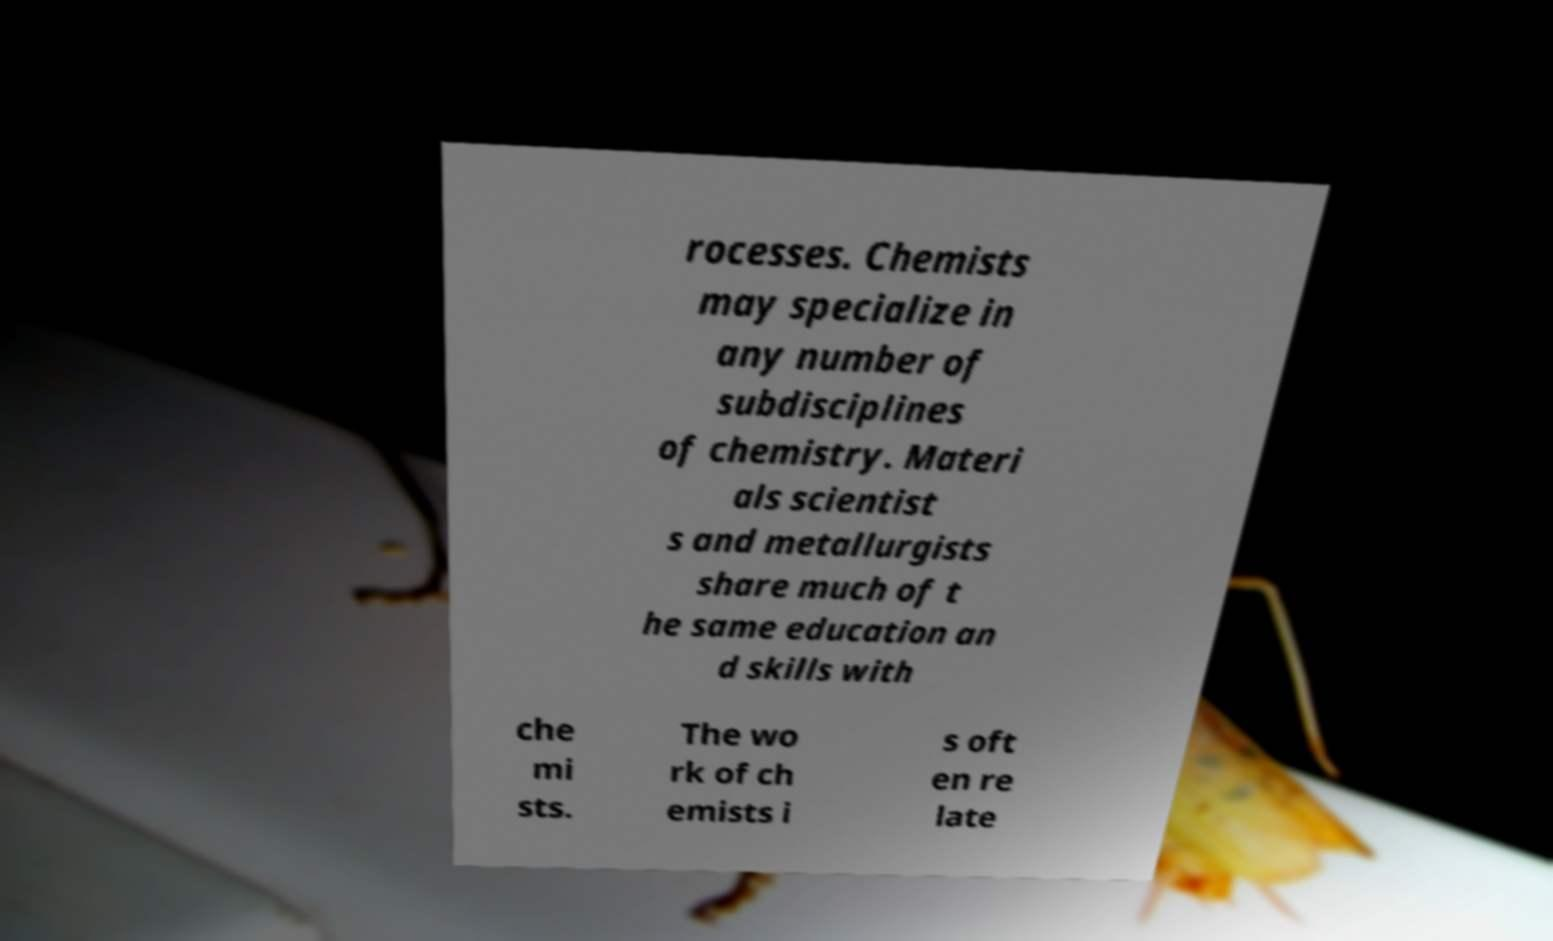Can you accurately transcribe the text from the provided image for me? rocesses. Chemists may specialize in any number of subdisciplines of chemistry. Materi als scientist s and metallurgists share much of t he same education an d skills with che mi sts. The wo rk of ch emists i s oft en re late 